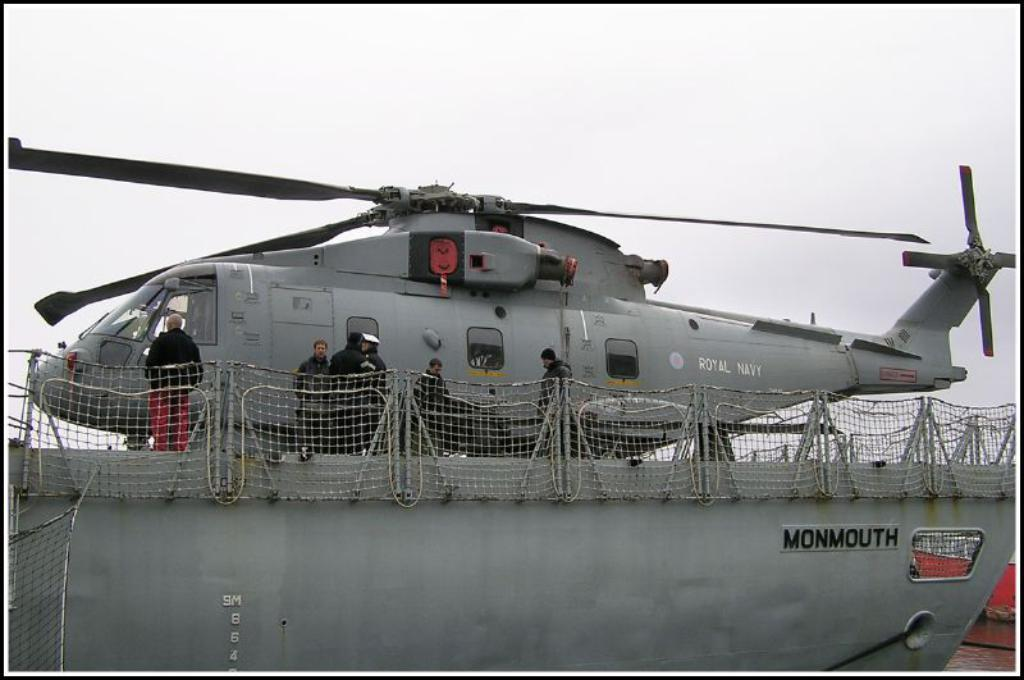<image>
Share a concise interpretation of the image provided. A military helicopter is parked on top of a ship called the Monmouth. 